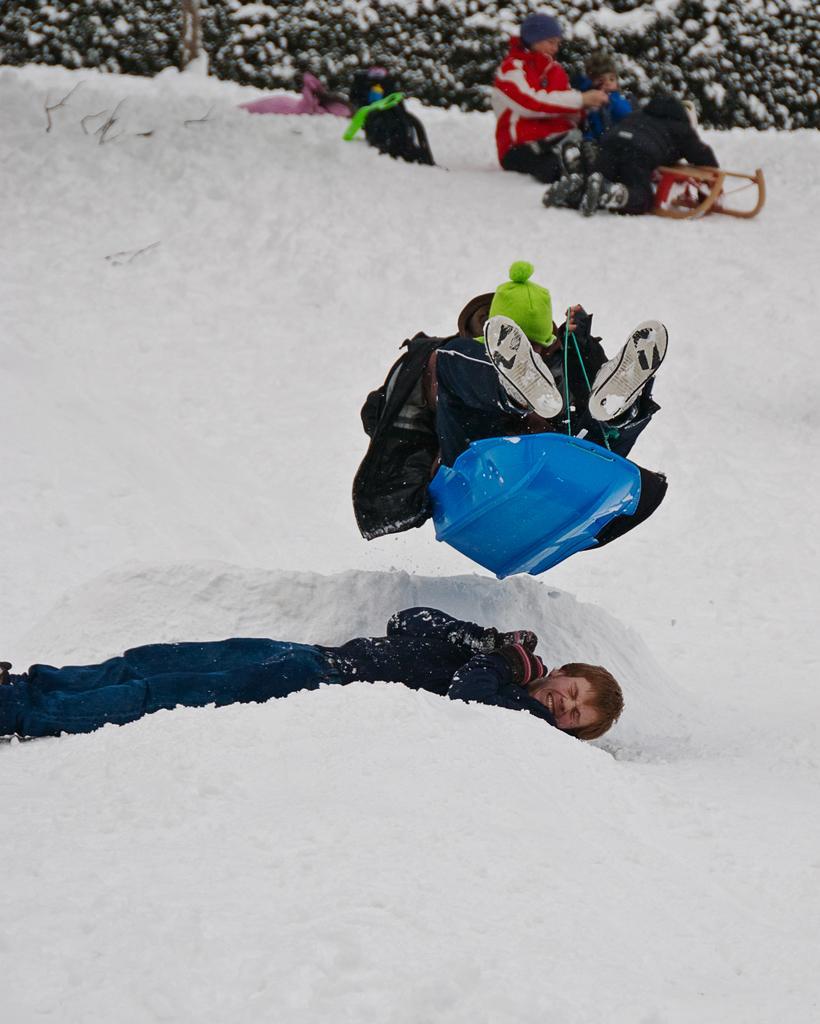Describe this image in one or two sentences. In the image we can see there are people, dying, jumping and sitting, they are wearing snow clothes. Everywhere there is snow, white in color and here we can see leaves. 